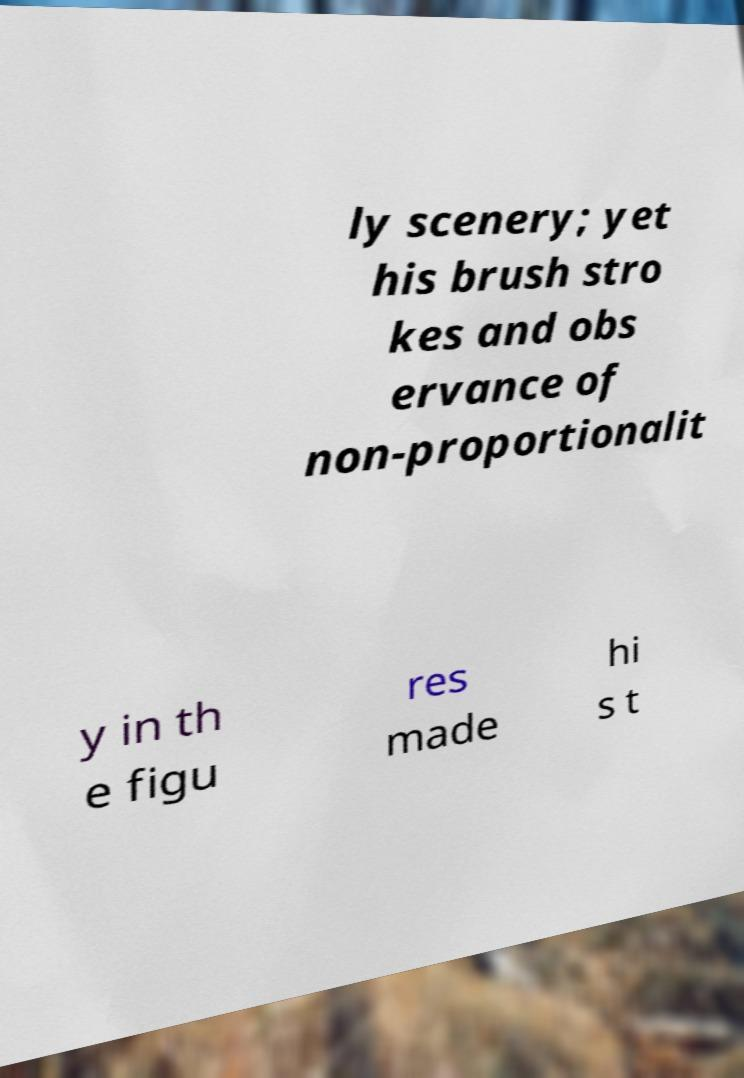What messages or text are displayed in this image? I need them in a readable, typed format. ly scenery; yet his brush stro kes and obs ervance of non-proportionalit y in th e figu res made hi s t 